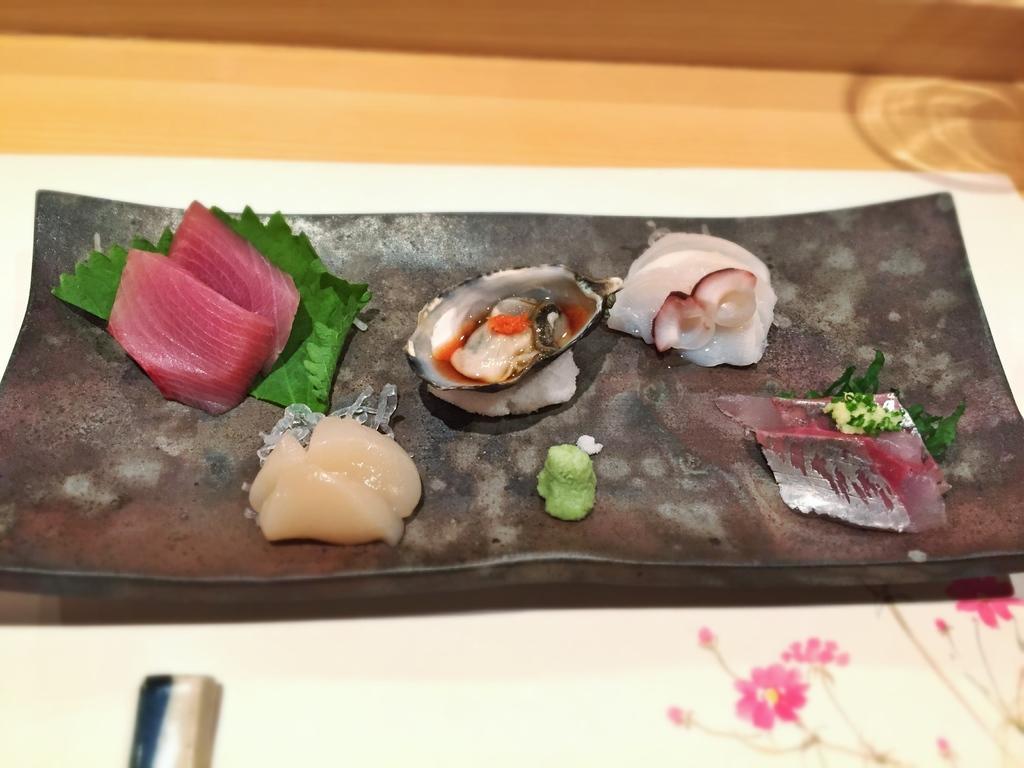Please provide a concise description of this image. In this image, we can see some food items on the tray. This tray is placed on the white surface. Top of the image, we can see wooden piece. 